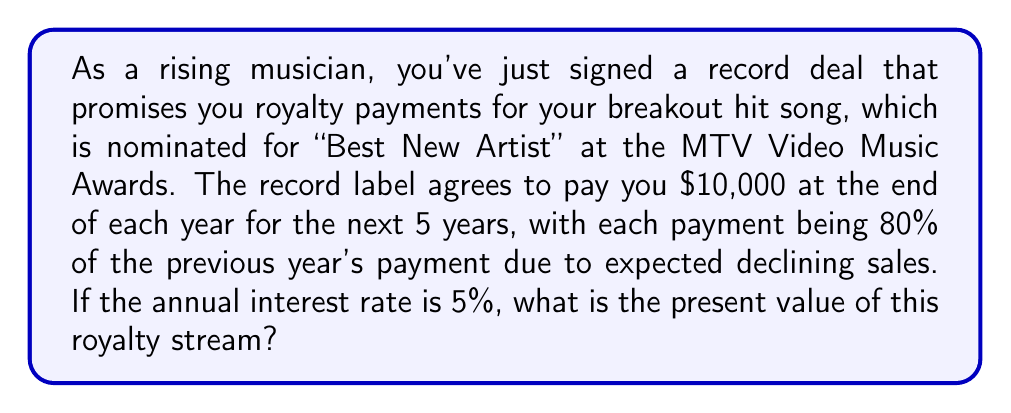Show me your answer to this math problem. To solve this problem, we need to use the concept of geometric series and the present value formula. Let's break it down step by step:

1) First, let's identify the components of our geometric series:
   - Initial payment: $a = 10000$
   - Common ratio: $r = 0.8$ (each payment is 80% of the previous)
   - Number of terms: $n = 5$ (5 years)
   - Interest rate: $i = 0.05$ (5%)

2) The payments form a geometric sequence: $10000, 8000, 6400, 5120, 4096$

3) To find the present value, we need to discount each payment back to the present. The present value formula for a geometric series is:

   $$PV = \frac{a(1-r^n(1+i)^{-n})}{1-r(1+i)^{-1}}$$

   Where:
   $PV$ is the present value
   $a$ is the initial payment
   $r$ is the common ratio
   $n$ is the number of payments
   $i$ is the interest rate

4) Let's substitute our values:

   $$PV = \frac{10000(1-0.8^5(1+0.05)^{-5})}{1-0.8(1+0.05)^{-1}}$$

5) Now, let's calculate step by step:
   
   $$PV = \frac{10000(1-0.32768 \times 0.78353)}{1-0.8 \times 0.95238}$$
   
   $$PV = \frac{10000(1-0.25675)}{1-0.76190}$$
   
   $$PV = \frac{10000(0.74325)}{0.23810}$$
   
   $$PV = \frac{7432.5}{0.23810}$$
   
   $$PV = 31216.30$$

6) Rounding to the nearest dollar, we get $31,216.
Answer: $31,216 